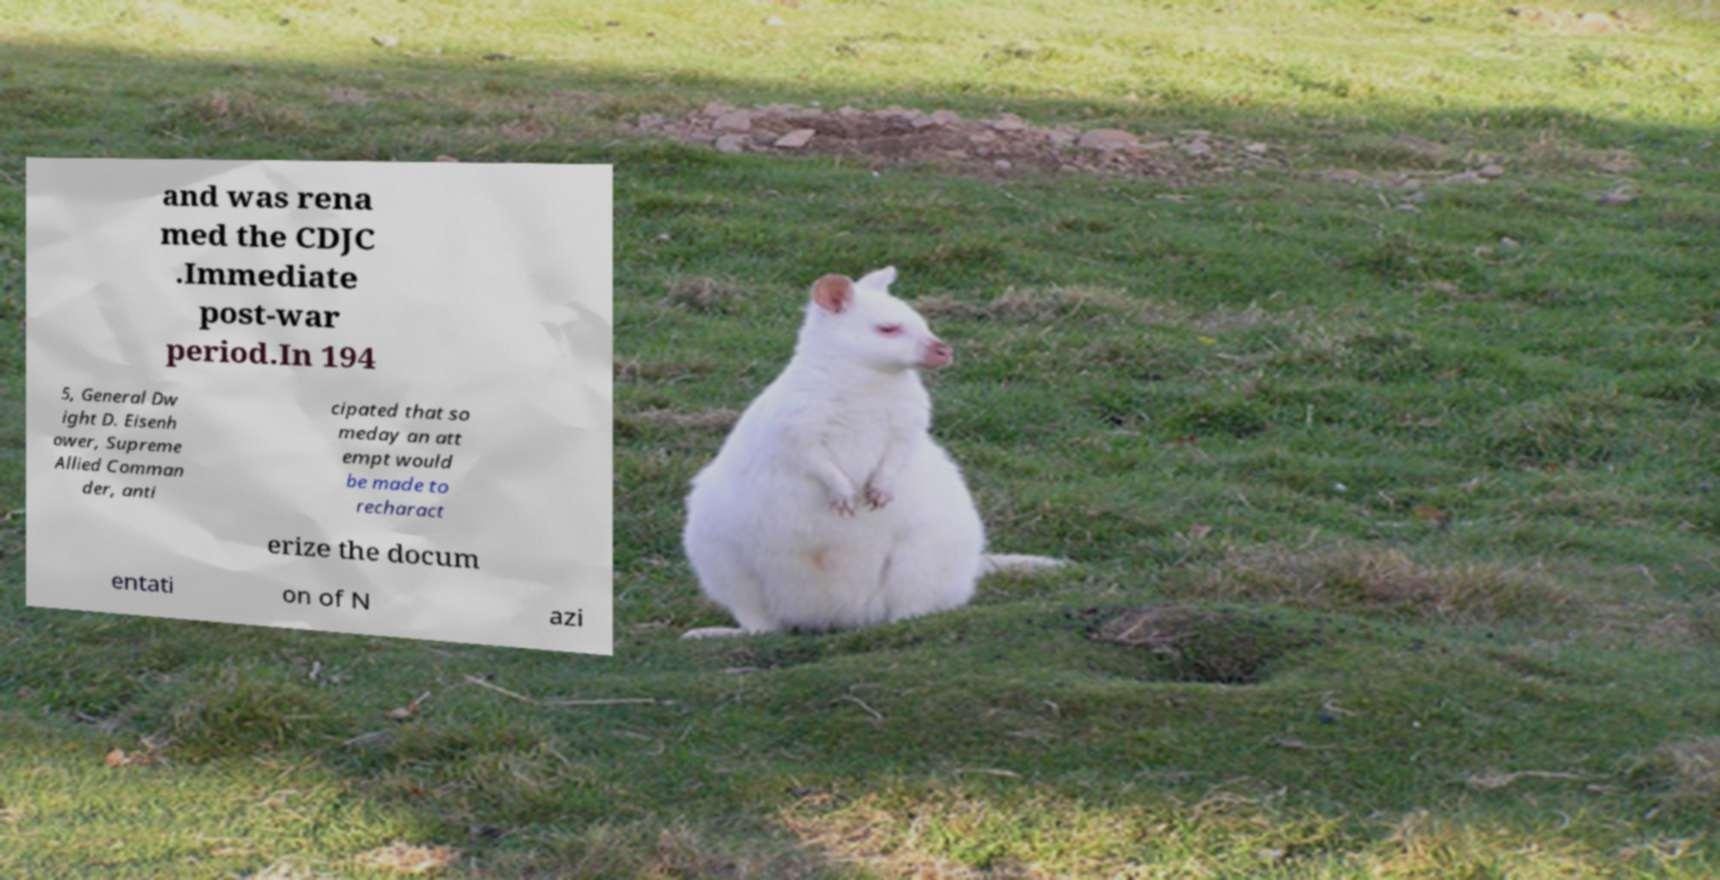For documentation purposes, I need the text within this image transcribed. Could you provide that? and was rena med the CDJC .Immediate post-war period.In 194 5, General Dw ight D. Eisenh ower, Supreme Allied Comman der, anti cipated that so meday an att empt would be made to recharact erize the docum entati on of N azi 